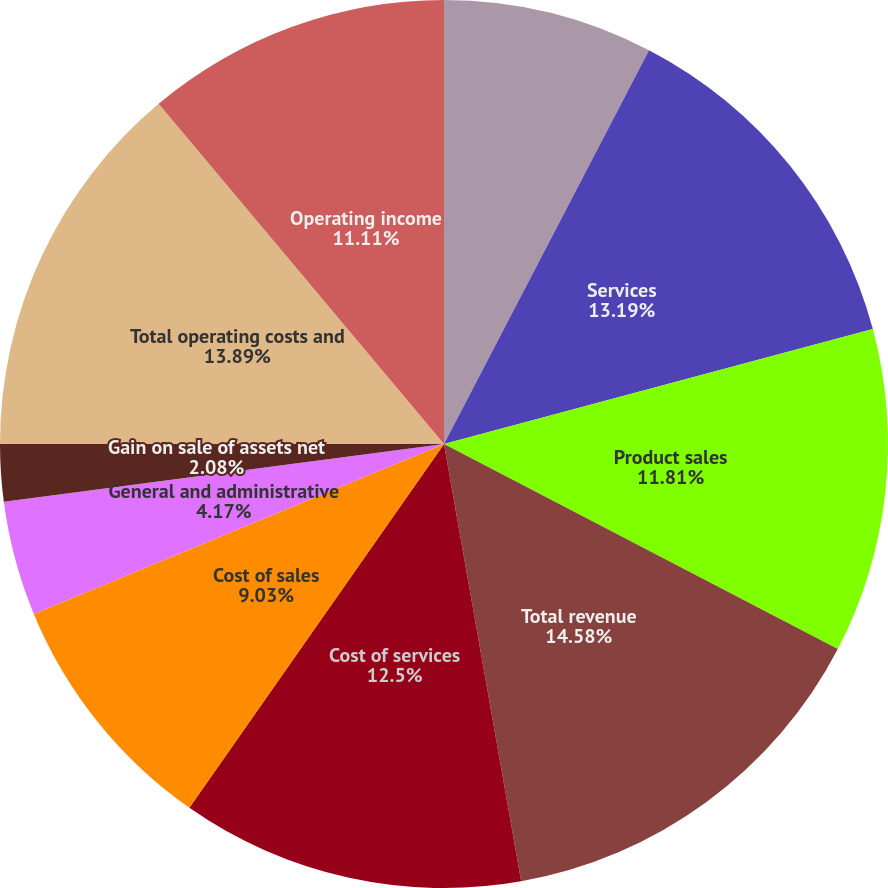Convert chart. <chart><loc_0><loc_0><loc_500><loc_500><pie_chart><fcel>Millions of dollars and shares<fcel>Services<fcel>Product sales<fcel>Total revenue<fcel>Cost of services<fcel>Cost of sales<fcel>General and administrative<fcel>Gain on sale of assets net<fcel>Total operating costs and<fcel>Operating income<nl><fcel>7.64%<fcel>13.19%<fcel>11.81%<fcel>14.58%<fcel>12.5%<fcel>9.03%<fcel>4.17%<fcel>2.08%<fcel>13.89%<fcel>11.11%<nl></chart> 